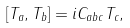Convert formula to latex. <formula><loc_0><loc_0><loc_500><loc_500>[ T _ { a } , T _ { b } ] = i C _ { a b c } T _ { c } ,</formula> 